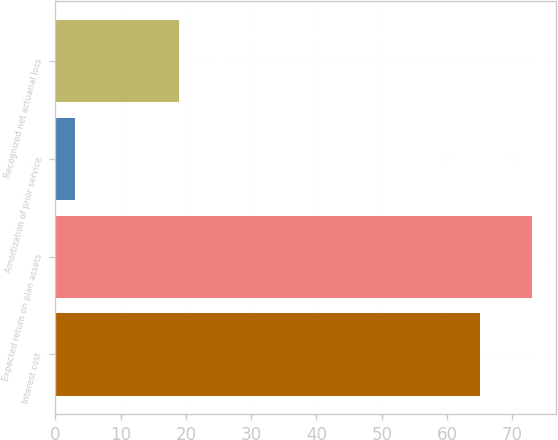Convert chart. <chart><loc_0><loc_0><loc_500><loc_500><bar_chart><fcel>Interest cost<fcel>Expected return on plan assets<fcel>Amortization of prior service<fcel>Recognized net actuarial loss<nl><fcel>65<fcel>73<fcel>3<fcel>19<nl></chart> 